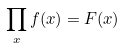Convert formula to latex. <formula><loc_0><loc_0><loc_500><loc_500>\prod _ { x } f ( x ) = F ( x )</formula> 